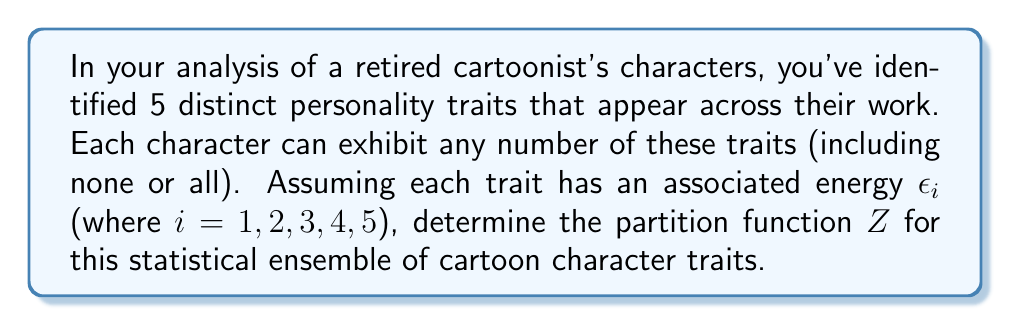Help me with this question. To solve this problem, we'll follow these steps:

1) In statistical mechanics, the partition function $Z$ is defined as the sum over all possible microstates of the system, each weighted by its Boltzmann factor:

   $$Z = \sum_i e^{-\beta E_i}$$

   where $\beta = \frac{1}{k_B T}$, $k_B$ is Boltzmann's constant, and $T$ is temperature.

2) In our case, each microstate corresponds to a possible combination of traits. For each trait, we have two possibilities: it's either present (contributing its energy $\epsilon_i$) or absent (contributing no energy).

3) This situation is analogous to a system of independent two-state systems. For each trait, we have:

   $$z_i = 1 + e^{-\beta \epsilon_i}$$

   where 1 represents the absence of the trait, and $e^{-\beta \epsilon_i}$ represents its presence.

4) Since the traits are independent, the total partition function is the product of the individual partition functions:

   $$Z = \prod_{i=1}^5 (1 + e^{-\beta \epsilon_i})$$

5) Expanding this product:

   $$Z = (1 + e^{-\beta \epsilon_1})(1 + e^{-\beta \epsilon_2})(1 + e^{-\beta \epsilon_3})(1 + e^{-\beta \epsilon_4})(1 + e^{-\beta \epsilon_5})$$

This is the partition function for our ensemble of cartoon character traits.
Answer: $$Z = \prod_{i=1}^5 (1 + e^{-\beta \epsilon_i})$$ 